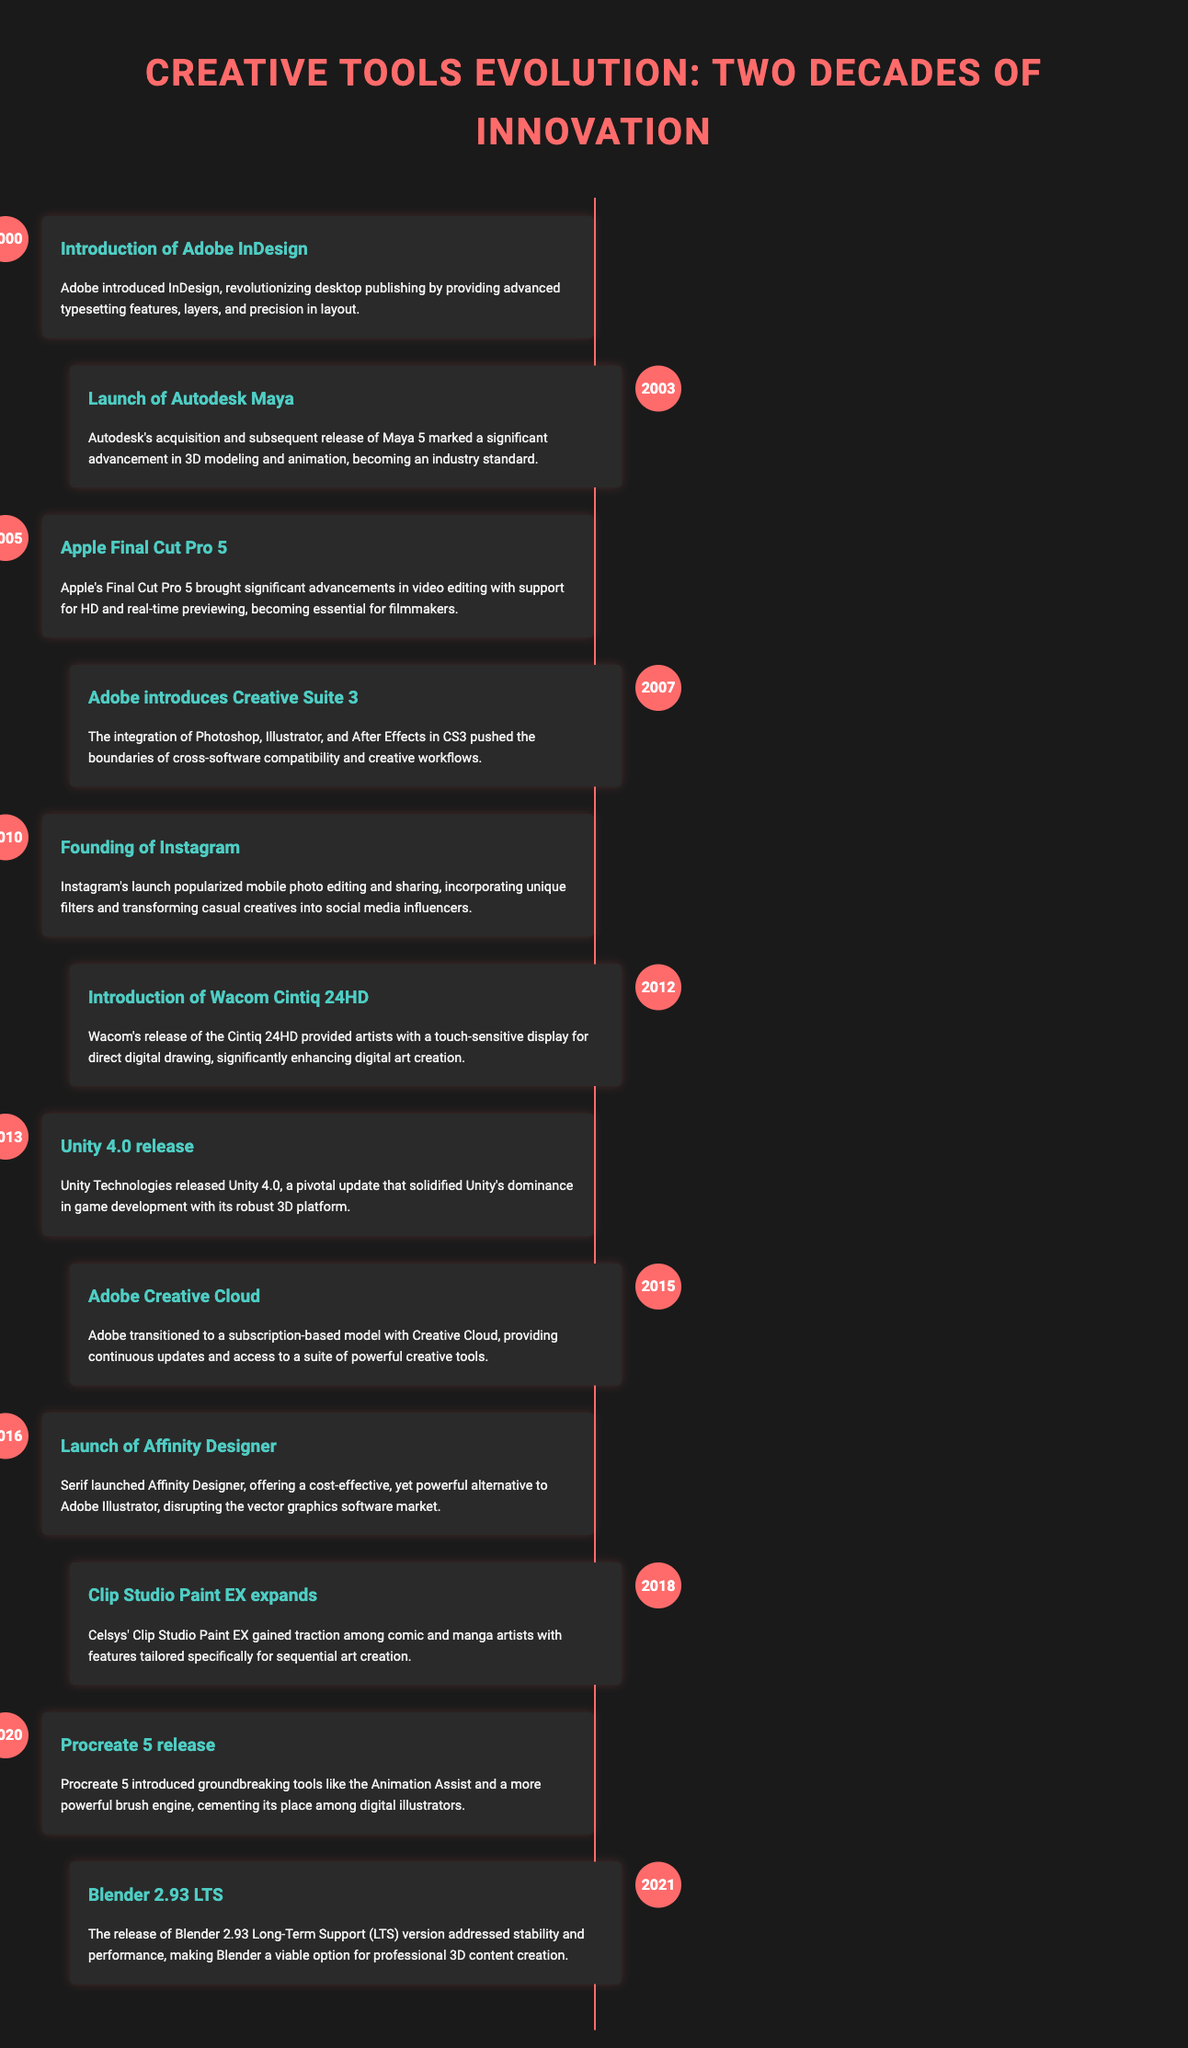What year was Adobe InDesign introduced? The document states that Adobe InDesign was introduced in the year 2000.
Answer: 2000 What software was launched in 2003? The timeline mentions the launch of Autodesk Maya in 2003.
Answer: Autodesk Maya Which version of Final Cut Pro was released in 2005? According to the document, Final Cut Pro 5 was released in 2005.
Answer: Final Cut Pro 5 What significant change occurred with Adobe in 2015? The document notes that Adobe transitioned to a subscription-based model with Creative Cloud in 2015.
Answer: Creative Cloud Which tool was popularized by the founding of Instagram in 2010? The document indicates that Instagram popularized mobile photo editing.
Answer: Mobile photo editing Why is the launch of Affinity Designer in 2016 significant? The document highlights Affinity Designer as a cost-effective alternative disrupting Adobe Illustrator.
Answer: Cost-effective alternative What major feature was introduced with Procreate 5 in 2020? The document mentions that Procreate 5 introduced Animation Assist among other tools.
Answer: Animation Assist How did Blender 2.93 LTS contribute to the industry in 2021? The timeline describes Blender 2.93 LTS as addressing stability and performance for professional content creation.
Answer: Stability and performance What type of document is this? The content is presented in a timeline infographic format, showcasing the evolution of creative tools.
Answer: Timeline infographic 